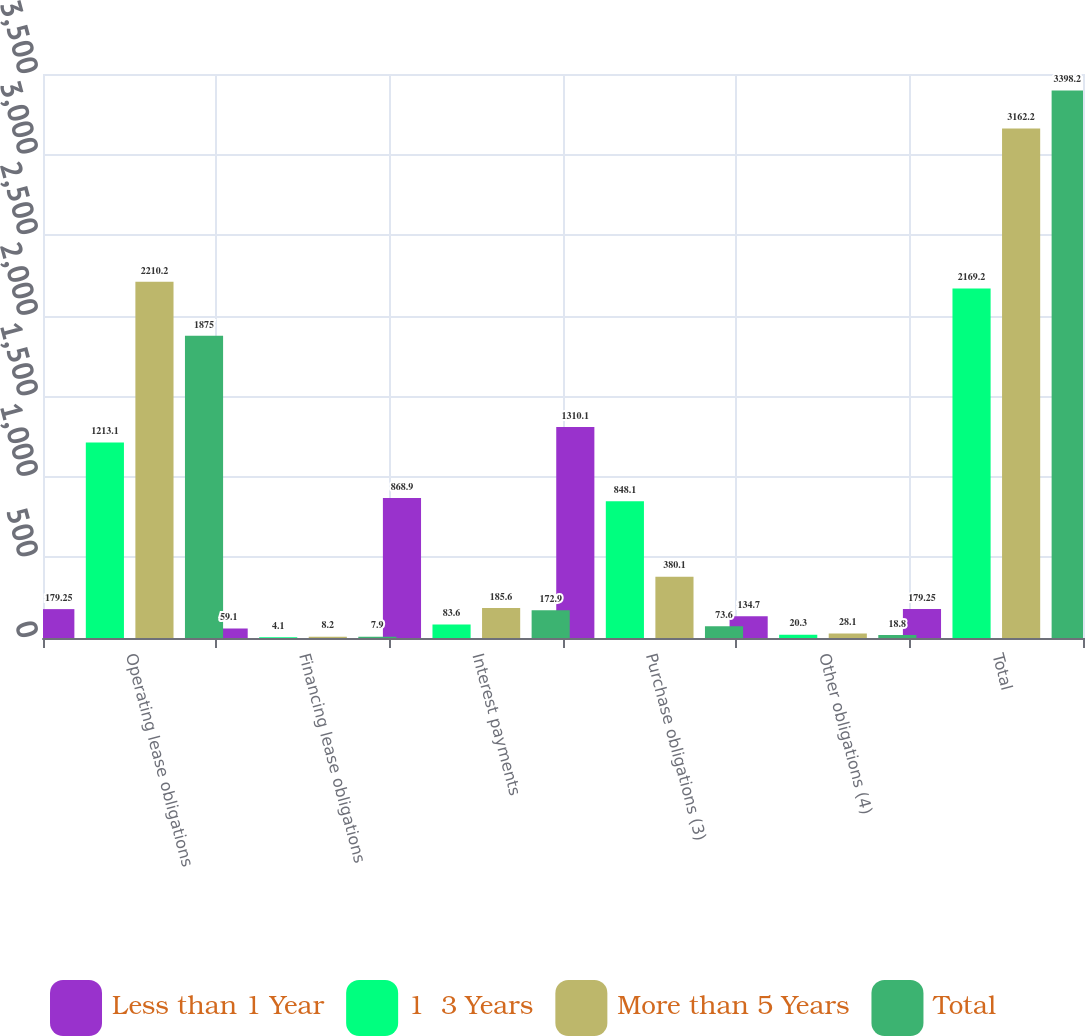Convert chart to OTSL. <chart><loc_0><loc_0><loc_500><loc_500><stacked_bar_chart><ecel><fcel>Operating lease obligations<fcel>Financing lease obligations<fcel>Interest payments<fcel>Purchase obligations (3)<fcel>Other obligations (4)<fcel>Total<nl><fcel>Less than 1 Year<fcel>179.25<fcel>59.1<fcel>868.9<fcel>1310.1<fcel>134.7<fcel>179.25<nl><fcel>1  3 Years<fcel>1213.1<fcel>4.1<fcel>83.6<fcel>848.1<fcel>20.3<fcel>2169.2<nl><fcel>More than 5 Years<fcel>2210.2<fcel>8.2<fcel>185.6<fcel>380.1<fcel>28.1<fcel>3162.2<nl><fcel>Total<fcel>1875<fcel>7.9<fcel>172.9<fcel>73.6<fcel>18.8<fcel>3398.2<nl></chart> 